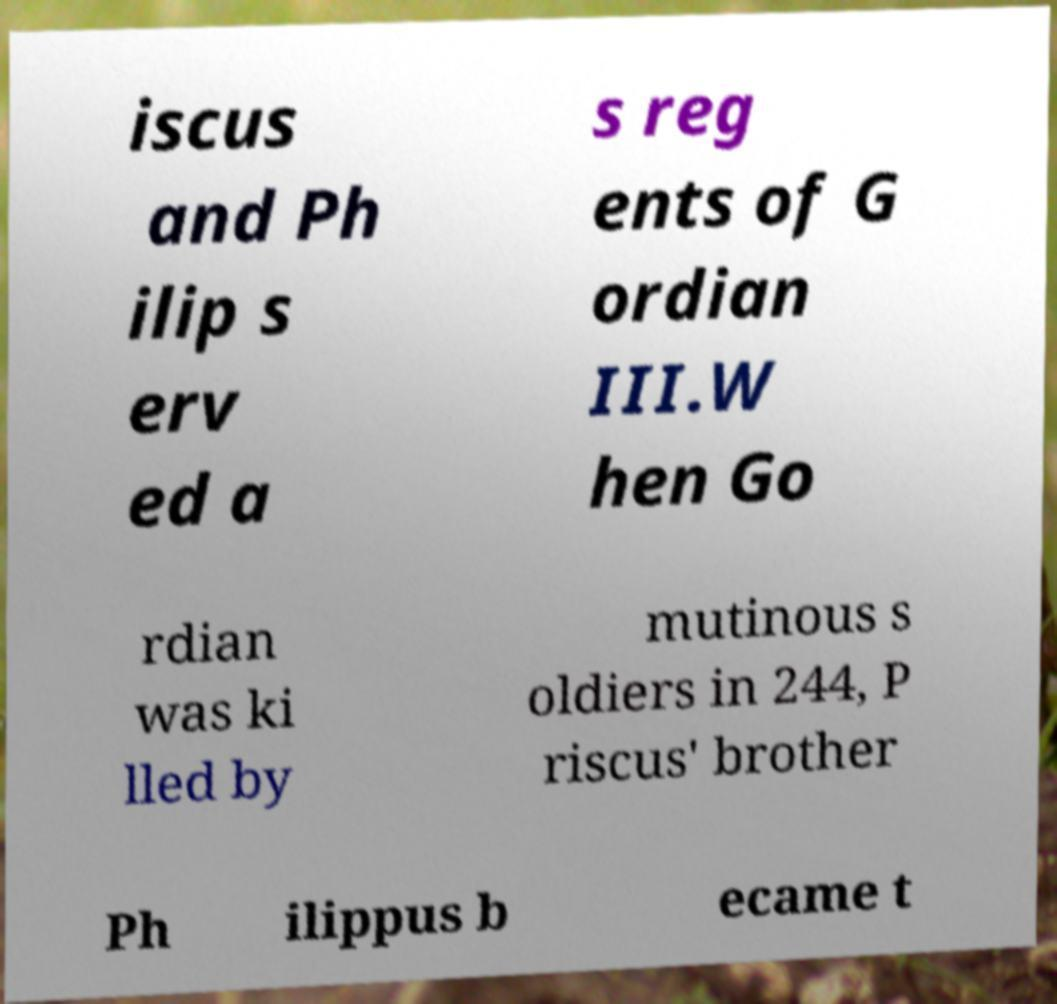Can you read and provide the text displayed in the image?This photo seems to have some interesting text. Can you extract and type it out for me? iscus and Ph ilip s erv ed a s reg ents of G ordian III.W hen Go rdian was ki lled by mutinous s oldiers in 244, P riscus' brother Ph ilippus b ecame t 